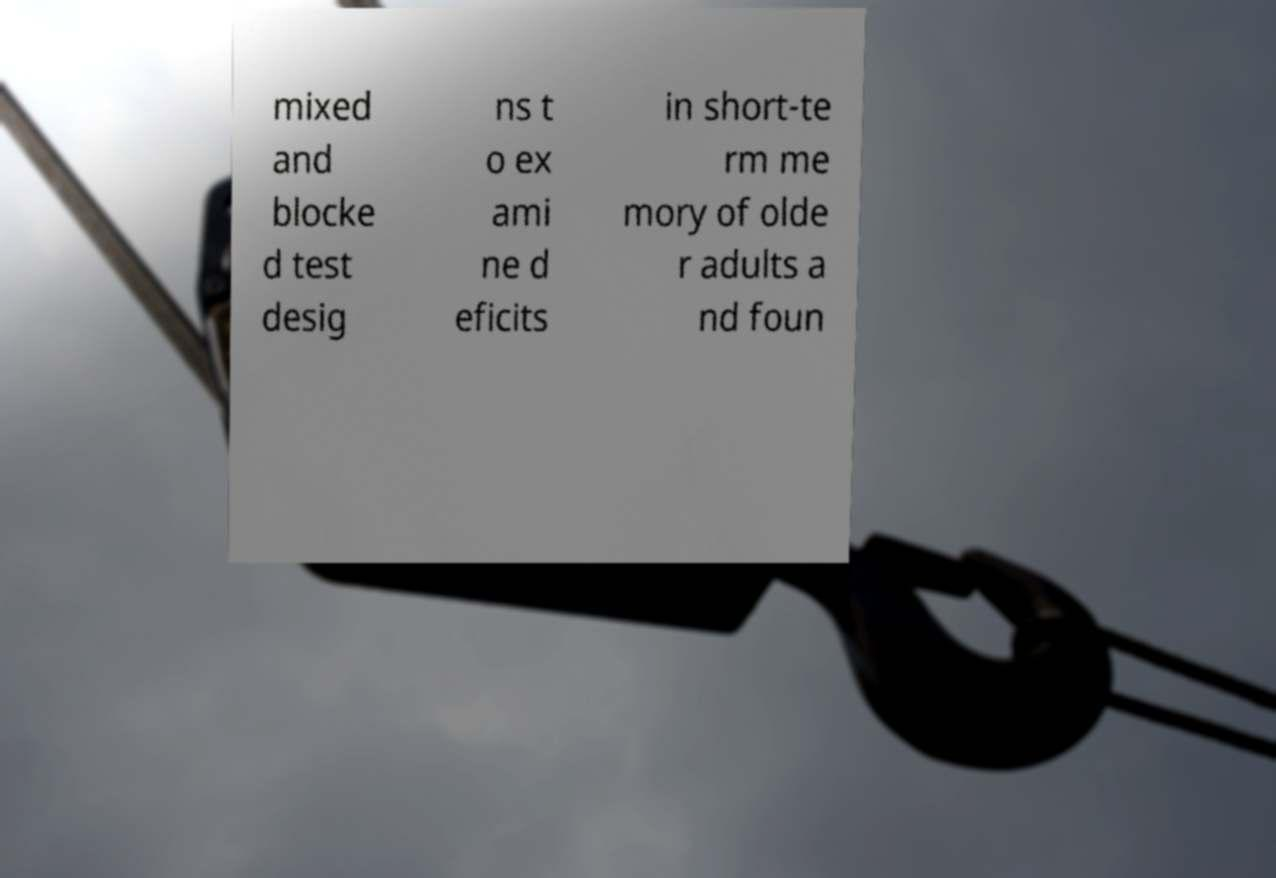Can you accurately transcribe the text from the provided image for me? mixed and blocke d test desig ns t o ex ami ne d eficits in short-te rm me mory of olde r adults a nd foun 